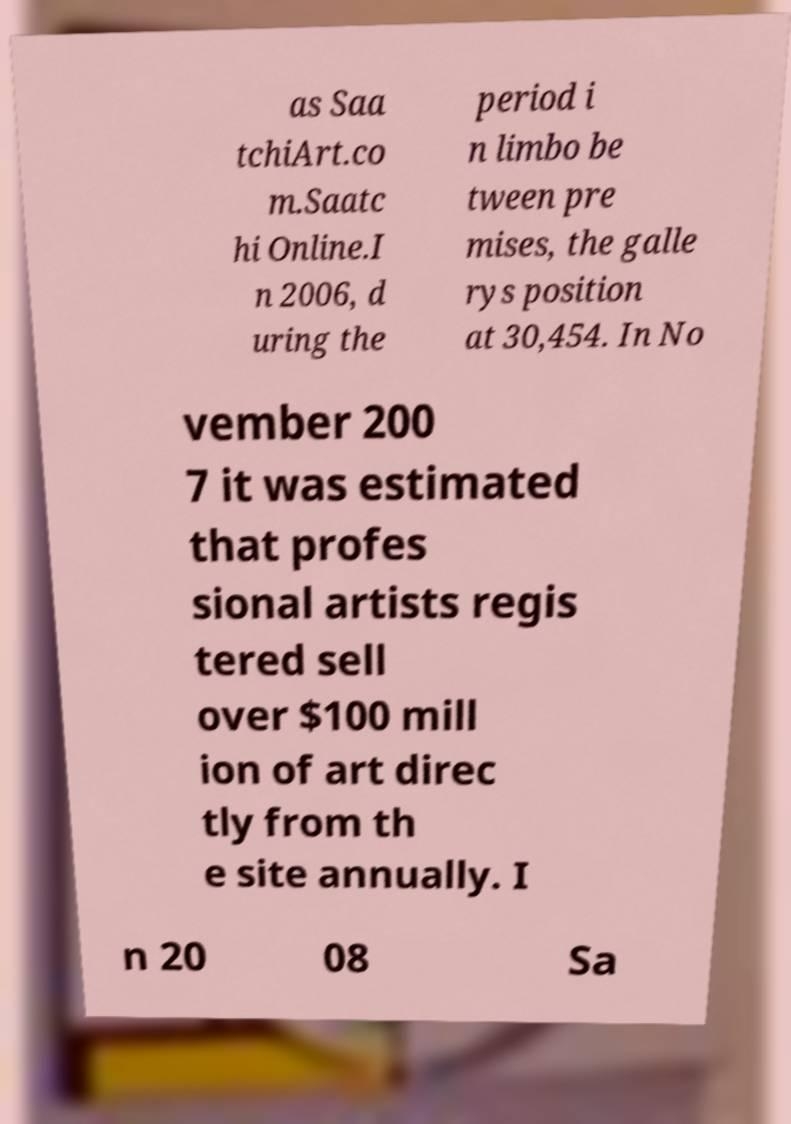Could you extract and type out the text from this image? as Saa tchiArt.co m.Saatc hi Online.I n 2006, d uring the period i n limbo be tween pre mises, the galle rys position at 30,454. In No vember 200 7 it was estimated that profes sional artists regis tered sell over $100 mill ion of art direc tly from th e site annually. I n 20 08 Sa 